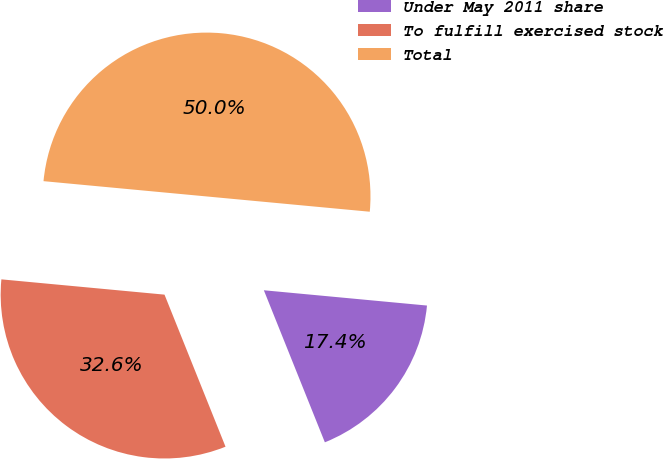<chart> <loc_0><loc_0><loc_500><loc_500><pie_chart><fcel>Under May 2011 share<fcel>To fulfill exercised stock<fcel>Total<nl><fcel>17.44%<fcel>32.56%<fcel>50.0%<nl></chart> 